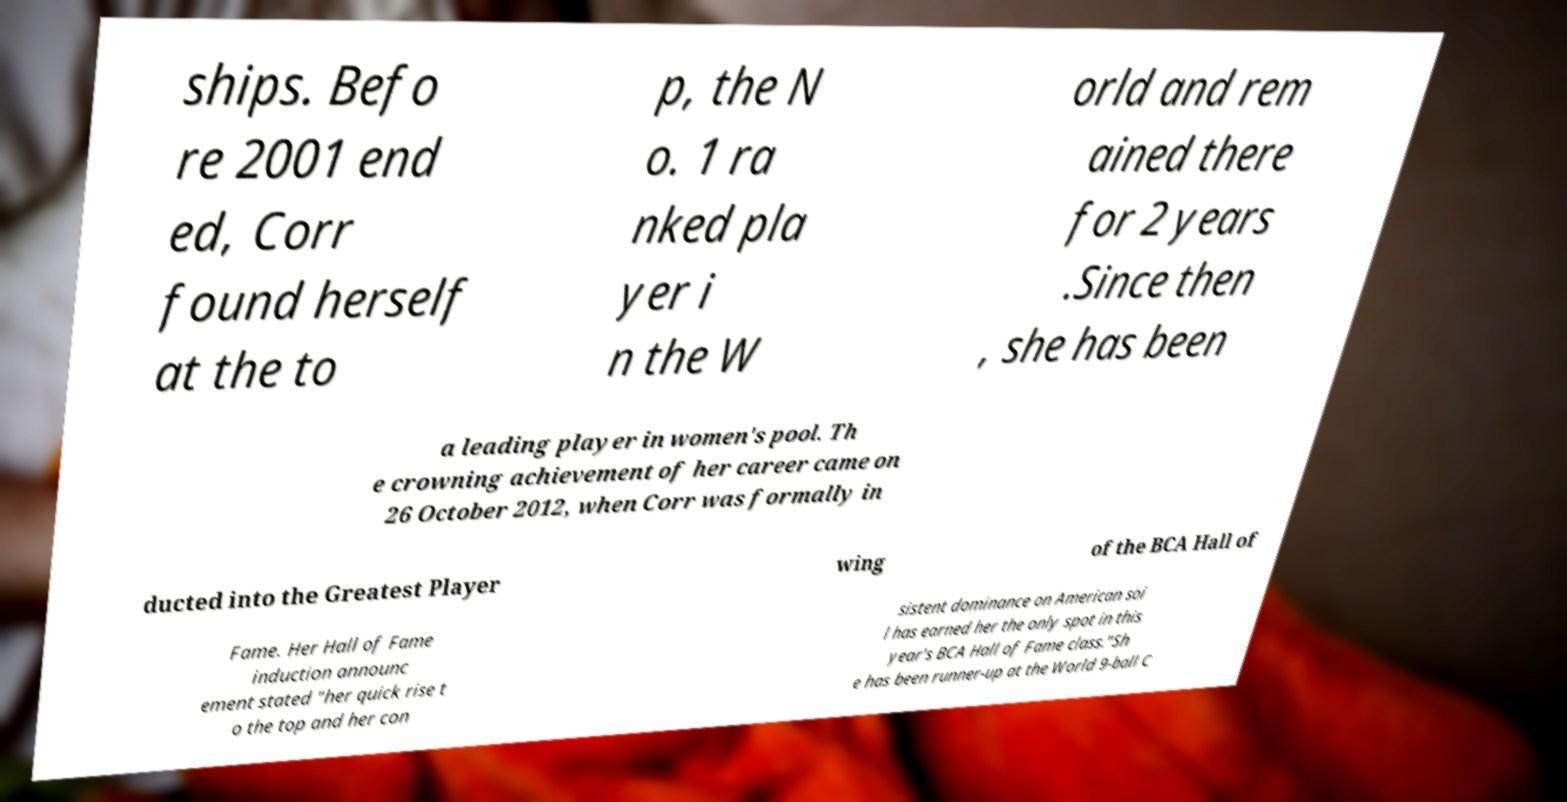Can you accurately transcribe the text from the provided image for me? ships. Befo re 2001 end ed, Corr found herself at the to p, the N o. 1 ra nked pla yer i n the W orld and rem ained there for 2 years .Since then , she has been a leading player in women's pool. Th e crowning achievement of her career came on 26 October 2012, when Corr was formally in ducted into the Greatest Player wing of the BCA Hall of Fame. Her Hall of Fame induction announc ement stated "her quick rise t o the top and her con sistent dominance on American soi l has earned her the only spot in this year's BCA Hall of Fame class."Sh e has been runner-up at the World 9-ball C 